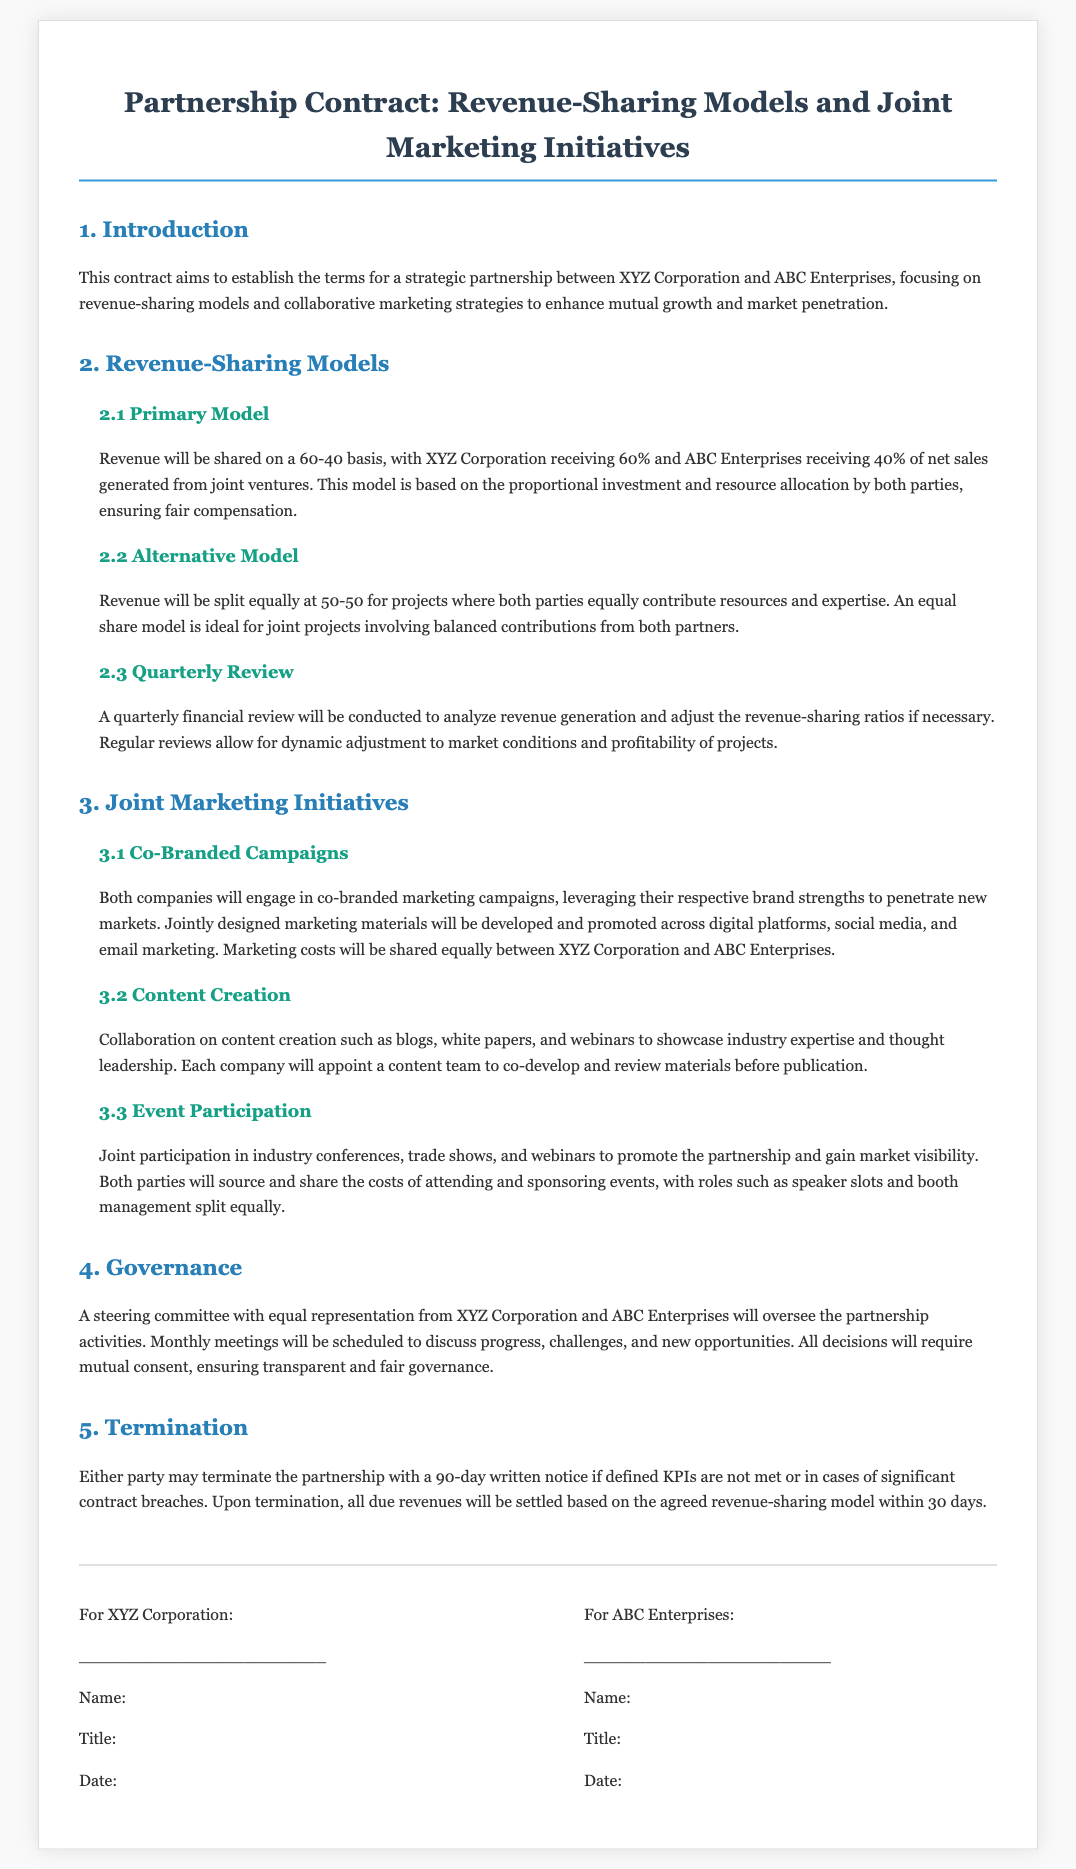what is the revenue-sharing ratio in the primary model? The primary model specifies a revenue-sharing ratio where XYZ Corporation receives 60% and ABC Enterprises receives 40% of net sales.
Answer: 60-40 what percentage of revenue will each company receive in the alternative model? In the alternative model, revenue will be split equally, meaning both parties will receive 50%.
Answer: 50-50 how often will the quarterly financial review occur? The document states that a quarterly review will be conducted, suggesting it takes place every three months.
Answer: Quarterly what type of marketing initiatives are emphasized in the contract? The contract emphasizes joint marketing initiatives, specifically co-branded campaigns, content creation, and event participation.
Answer: Joint marketing initiatives who will oversee the partnership activities? A steering committee with equal representation from both companies will oversee the activities, ensuring balanced governance.
Answer: Steering committee what is required for either party to terminate the partnership? Either party must provide a 90-day written notice for termination under specified conditions like unmet KPIs.
Answer: 90-day written notice how will joint marketing campaign costs be shared? The costs for co-branded marketing campaigns will be shared equally between XYZ Corporation and ABC Enterprises.
Answer: Shared equally what is the purpose of this partnership contract? The contract aims to establish the terms for a strategic partnership focusing on revenue-sharing models and collaborative marketing strategies.
Answer: Strategic partnership when must all due revenues be settled after termination? Upon termination, all due revenues must be settled within 30 days based on the agreed revenue-sharing model.
Answer: 30 days 